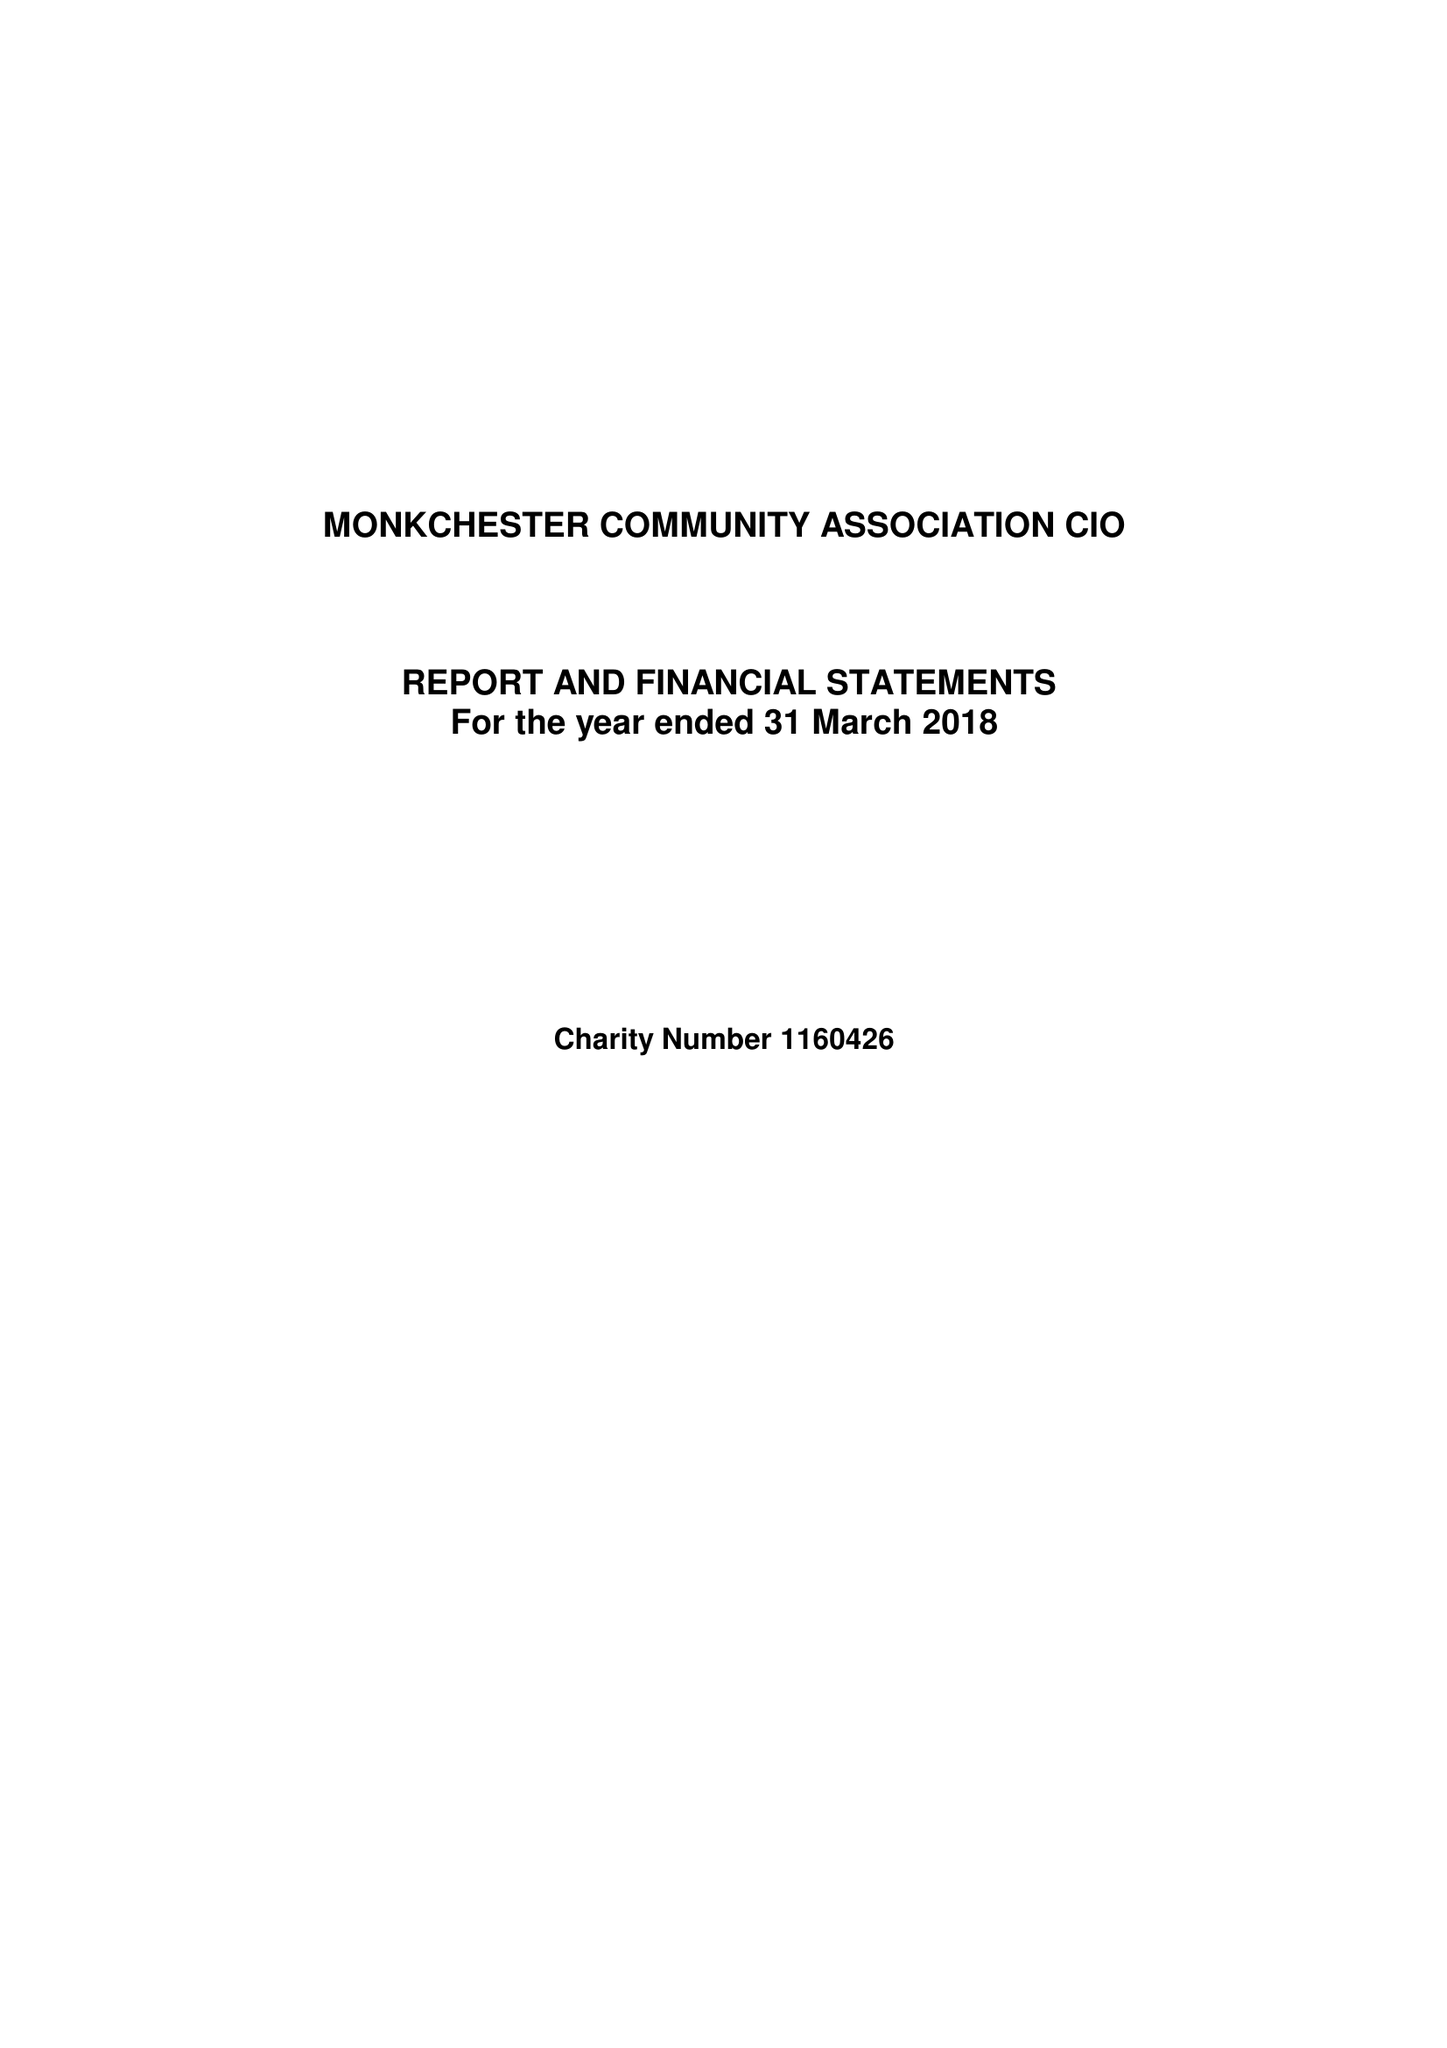What is the value for the charity_number?
Answer the question using a single word or phrase. 1160426 